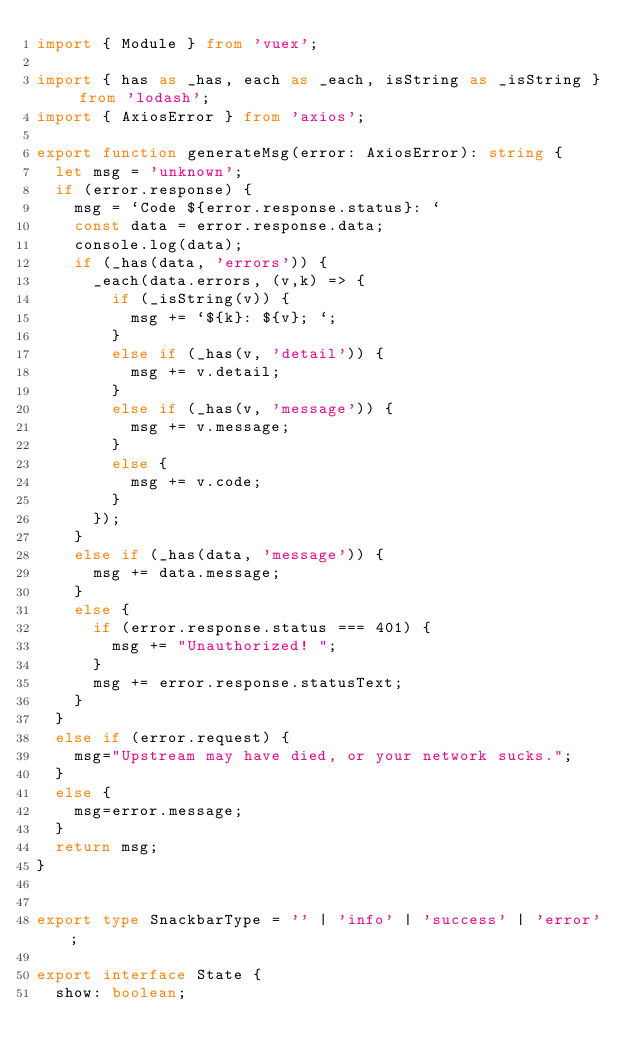<code> <loc_0><loc_0><loc_500><loc_500><_TypeScript_>import { Module } from 'vuex';

import { has as _has, each as _each, isString as _isString } from 'lodash';
import { AxiosError } from 'axios';

export function generateMsg(error: AxiosError): string {
  let msg = 'unknown';
  if (error.response) {
    msg = `Code ${error.response.status}: `
    const data = error.response.data;
    console.log(data);
    if (_has(data, 'errors')) {
      _each(data.errors, (v,k) => {
        if (_isString(v)) {
          msg += `${k}: ${v}; `;
        }
        else if (_has(v, 'detail')) {
          msg += v.detail;
        }
        else if (_has(v, 'message')) {
          msg += v.message;
        }
        else {
          msg += v.code;
        }
      });
    }
    else if (_has(data, 'message')) {
      msg += data.message;
    }
    else {
      if (error.response.status === 401) {
        msg += "Unauthorized! ";
      }
      msg += error.response.statusText;
    }
  }
  else if (error.request) {
    msg="Upstream may have died, or your network sucks.";
  }
  else {
    msg=error.message;
  }
  return msg;
}


export type SnackbarType = '' | 'info' | 'success' | 'error';

export interface State {
  show: boolean;</code> 